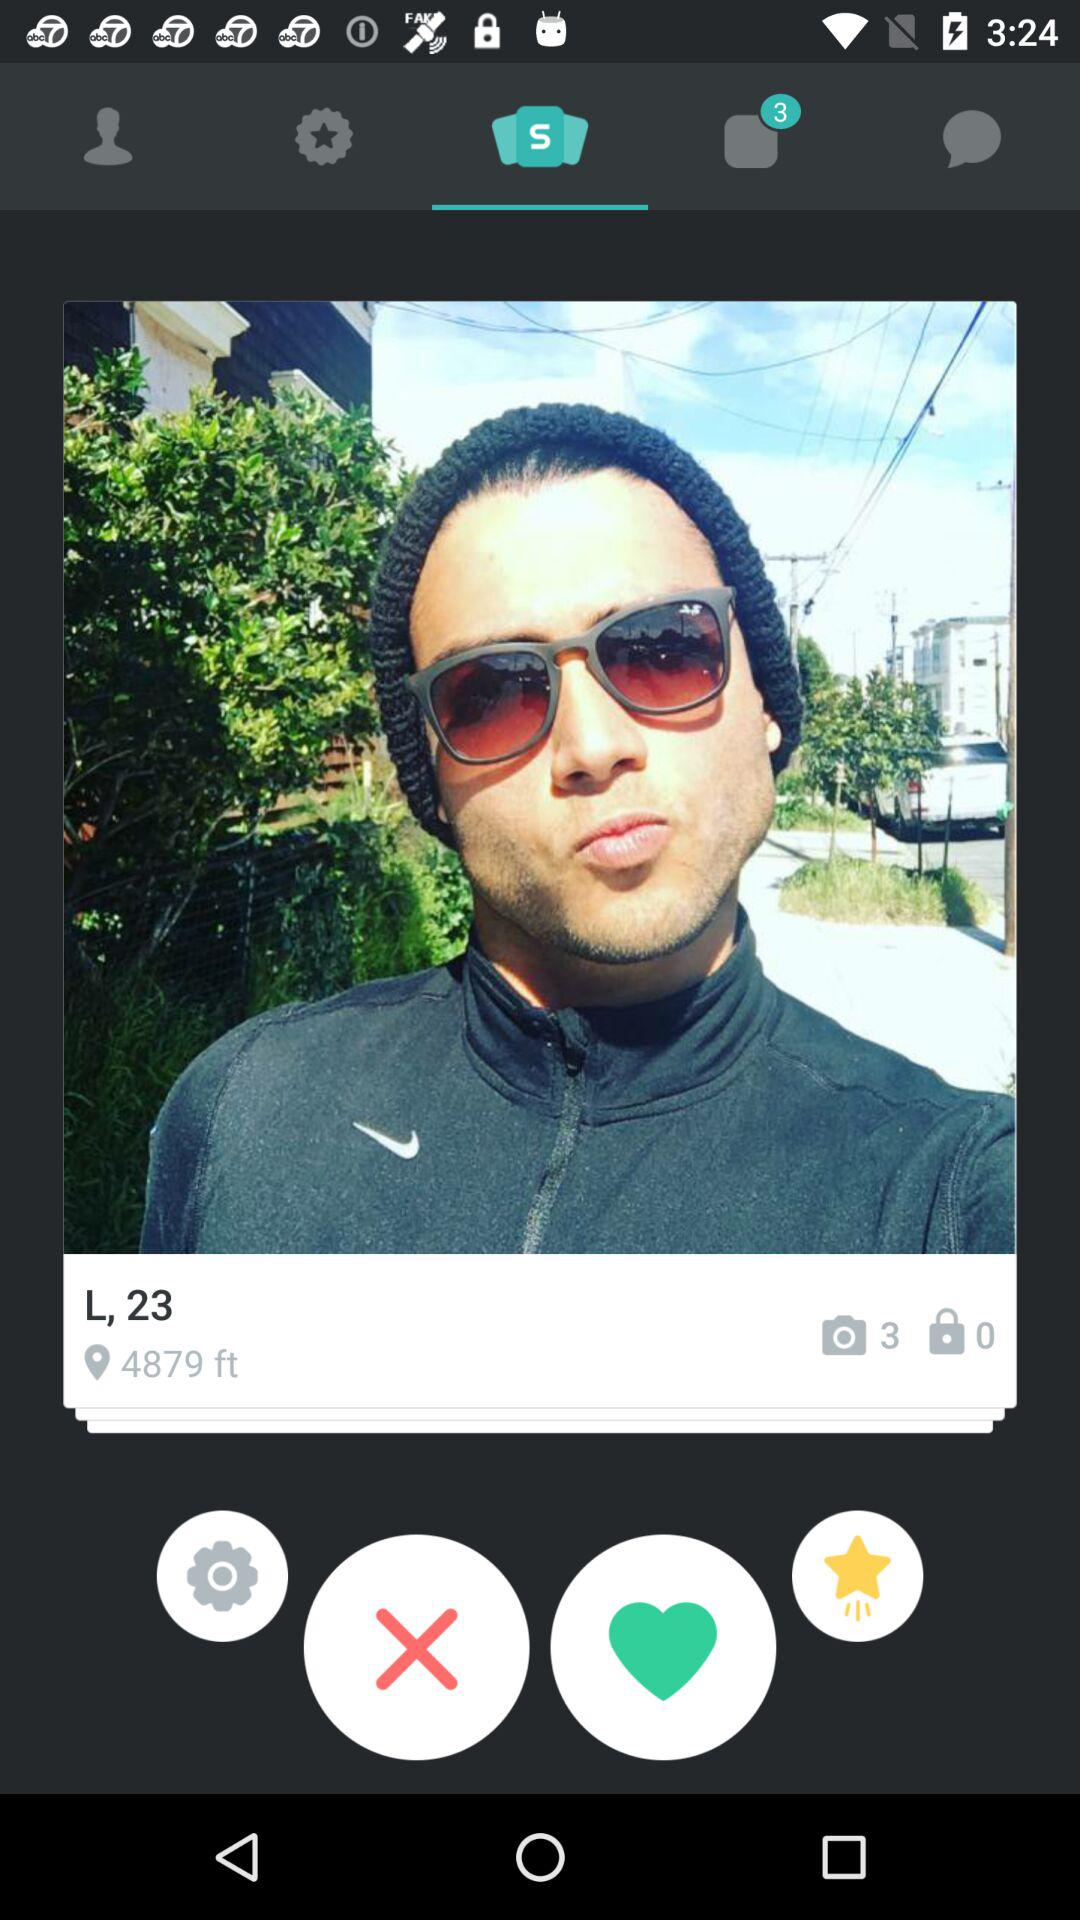What is the given height? The given height is 4879 feet. 